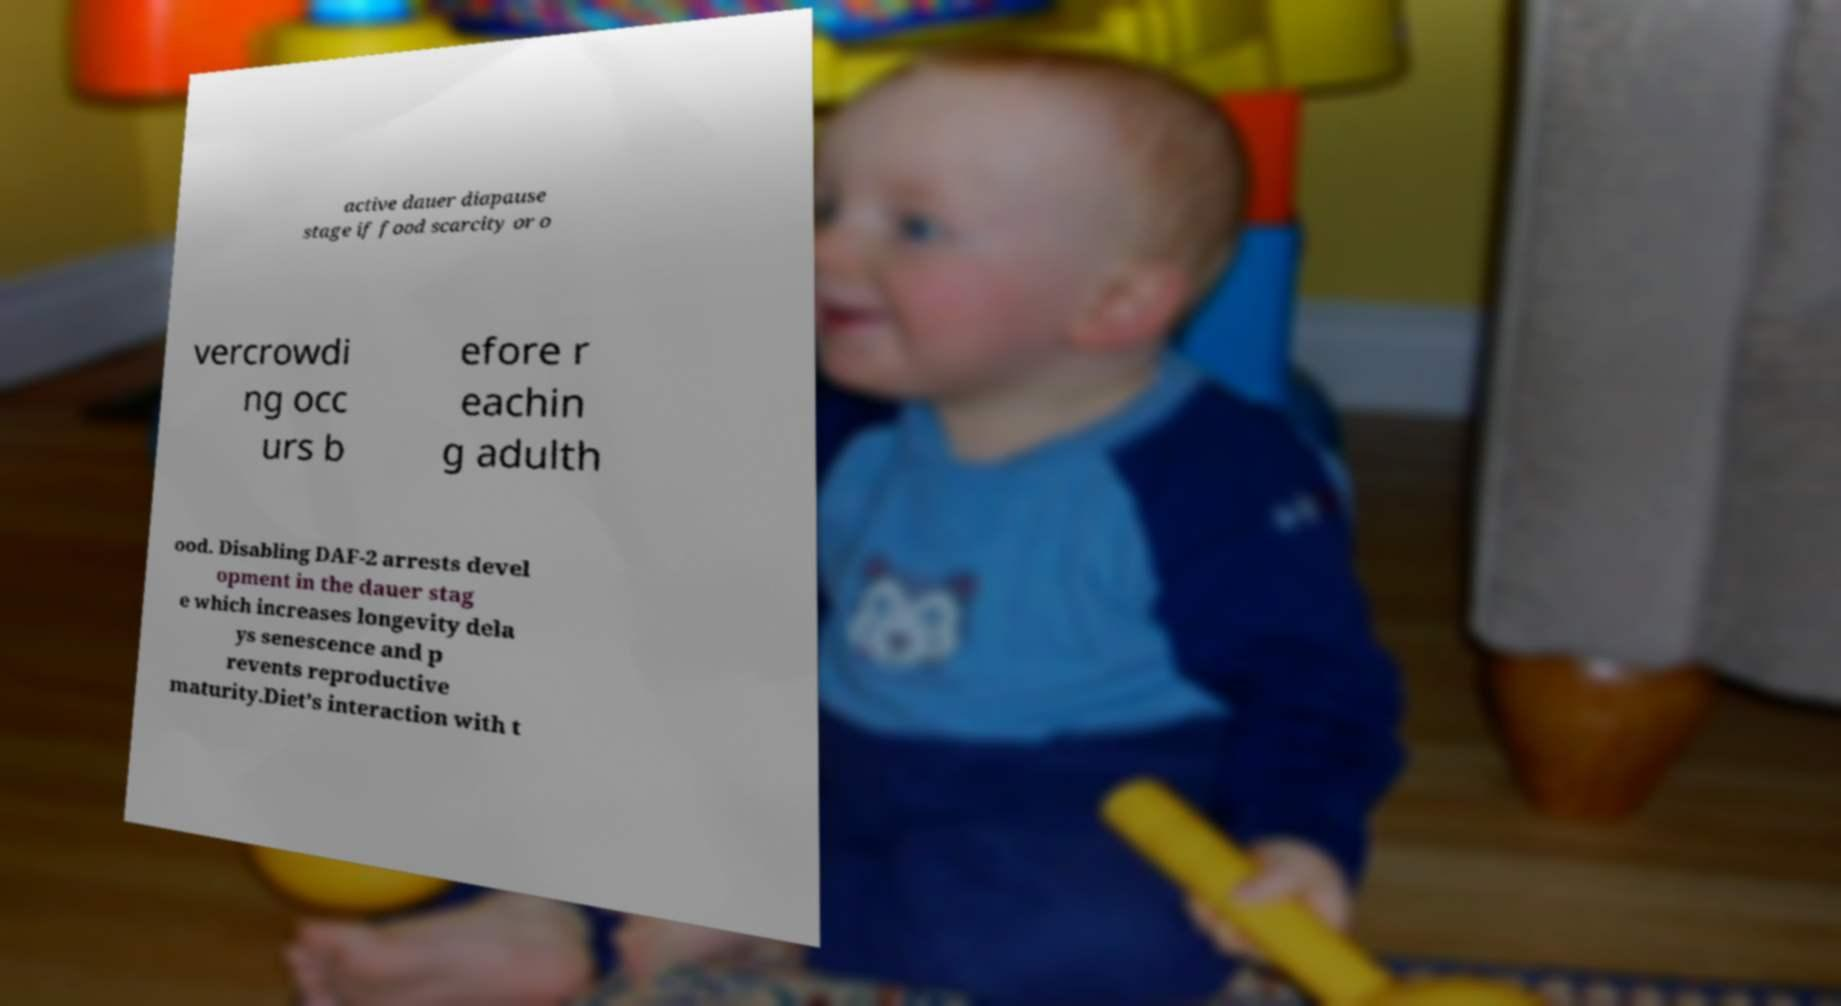Could you extract and type out the text from this image? active dauer diapause stage if food scarcity or o vercrowdi ng occ urs b efore r eachin g adulth ood. Disabling DAF-2 arrests devel opment in the dauer stag e which increases longevity dela ys senescence and p revents reproductive maturity.Diet’s interaction with t 